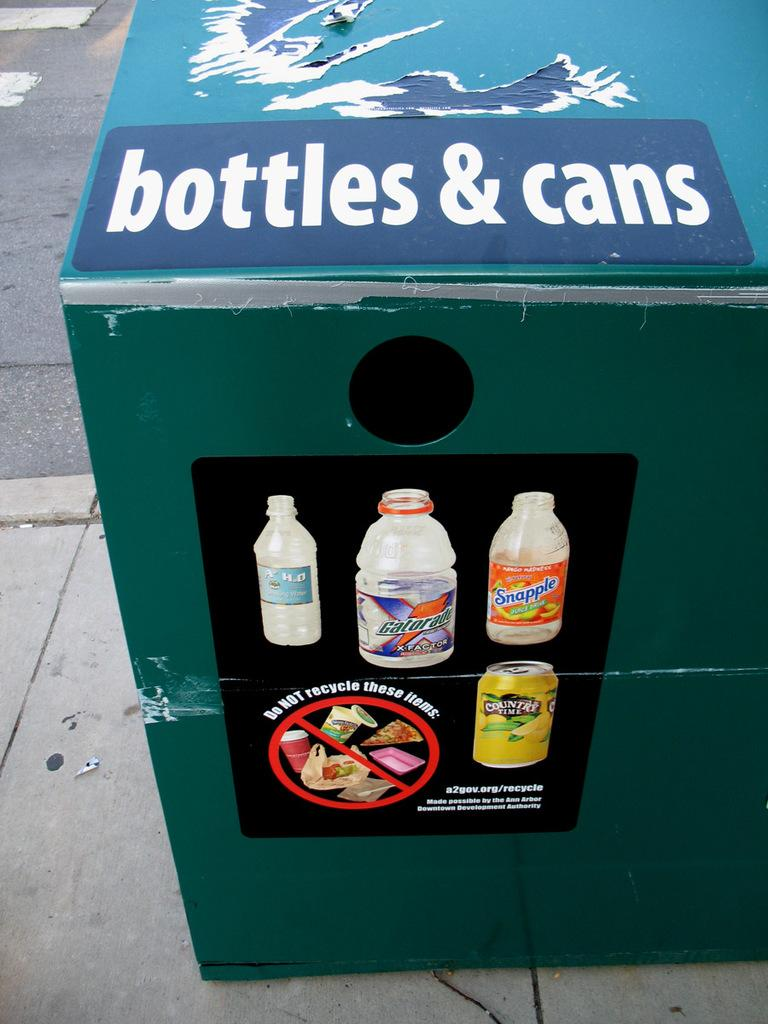Provide a one-sentence caption for the provided image. The container asks to not recycle certain items. 